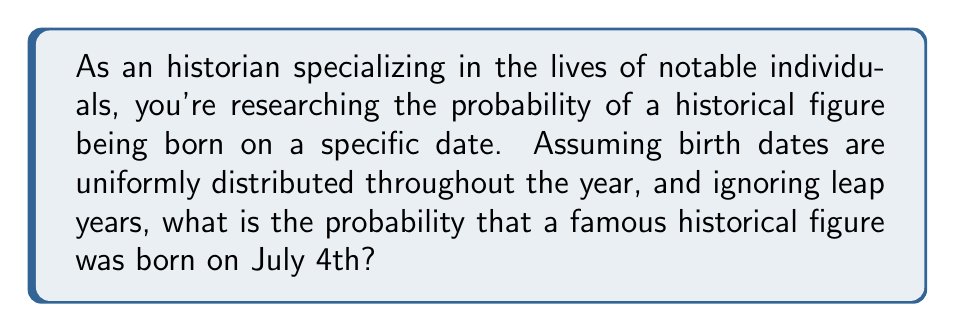Show me your answer to this math problem. To solve this problem, we need to consider the following:

1. In a non-leap year, there are 365 days.
2. We are assuming that birth dates are uniformly distributed, meaning each day has an equal probability of being someone's birthday.
3. We are specifically interested in July 4th, which is just one day out of the year.

The probability of an event occurring is calculated by dividing the number of favorable outcomes by the total number of possible outcomes:

$$ P(\text{event}) = \frac{\text{number of favorable outcomes}}{\text{total number of possible outcomes}} $$

In this case:
- The number of favorable outcomes is 1 (July 4th)
- The total number of possible outcomes is 365 (days in a year)

Therefore, the probability of a historical figure being born on July 4th is:

$$ P(\text{born on July 4th}) = \frac{1}{365} $$

This can be simplified to a decimal by performing the division:

$$ P(\text{born on July 4th}) \approx 0.002739726 $$

Or expressed as a percentage:

$$ P(\text{born on July 4th}) \approx 0.2739726\% $$
Answer: The probability of a historical figure being born on July 4th is $\frac{1}{365}$ or approximately $0.002739726$ (about $0.27\%$). 